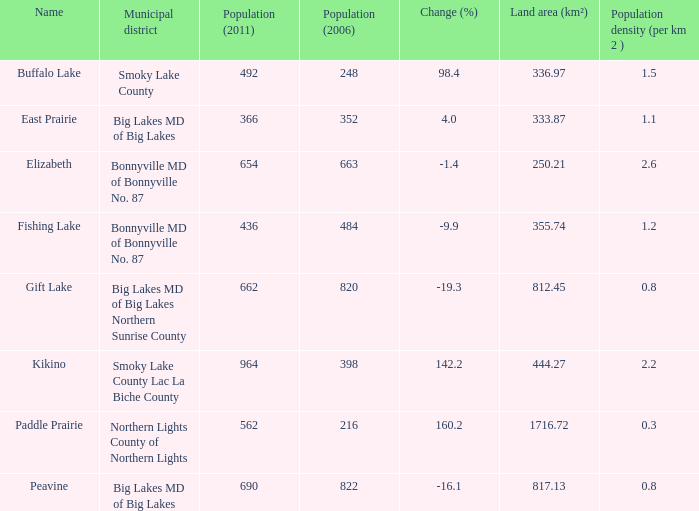In which location is there a decrease of -19.3? 1.0. 